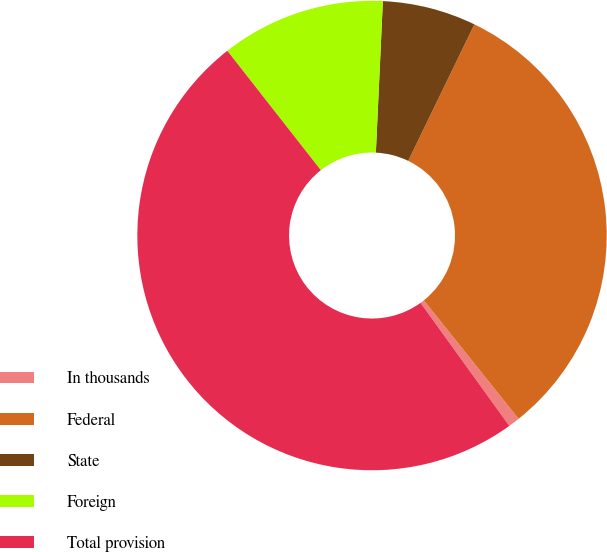Convert chart. <chart><loc_0><loc_0><loc_500><loc_500><pie_chart><fcel>In thousands<fcel>Federal<fcel>State<fcel>Foreign<fcel>Total provision<nl><fcel>0.79%<fcel>32.08%<fcel>6.45%<fcel>11.31%<fcel>49.37%<nl></chart> 